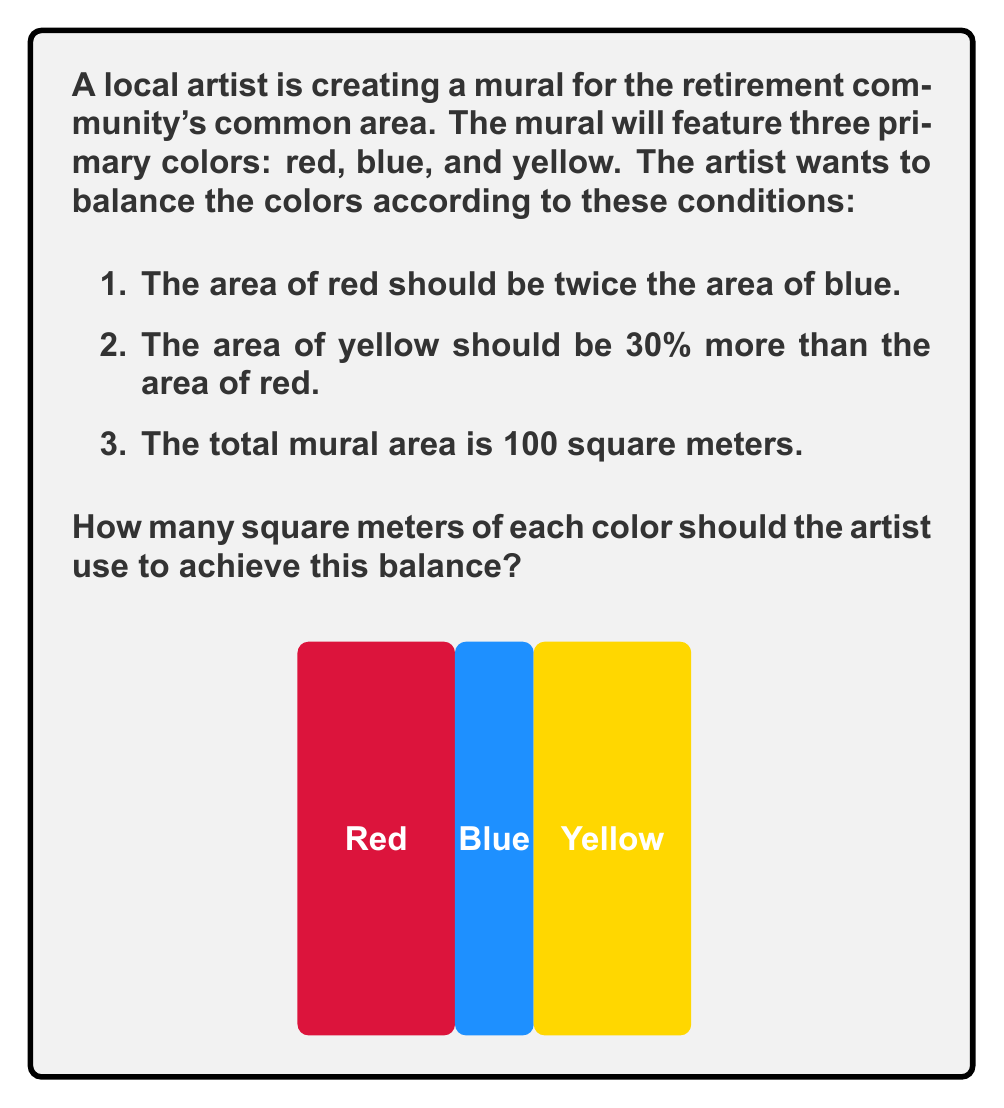What is the answer to this math problem? Let's solve this problem step by step using a system of linear equations:

1) Let's define our variables:
   $r$ = area of red
   $b$ = area of blue
   $y$ = area of yellow

2) Now, we can set up our equations based on the given conditions:
   
   Equation 1: $r = 2b$ (red is twice the area of blue)
   Equation 2: $y = 1.3r$ (yellow is 30% more than red)
   Equation 3: $r + b + y = 100$ (total area is 100 square meters)

3) Let's substitute the expressions for $r$ and $y$ into Equation 3:
   
   $2b + b + 1.3(2b) = 100$

4) Simplify:
   
   $2b + b + 2.6b = 100$
   $5.6b = 100$

5) Solve for $b$:
   
   $b = 100 / 5.6 = 17.86$ square meters

6) Now we can find $r$:
   
   $r = 2b = 2(17.86) = 35.72$ square meters

7) And finally, $y$:
   
   $y = 1.3r = 1.3(35.72) = 46.44$ square meters

8) Let's verify that these values sum to 100:
   
   $17.86 + 35.72 + 46.44 = 100.02$ (rounding error)

Therefore, the artist should use approximately 35.72 square meters of red, 17.86 square meters of blue, and 46.44 square meters of yellow.
Answer: Red: 35.72 m², Blue: 17.86 m², Yellow: 46.44 m² 